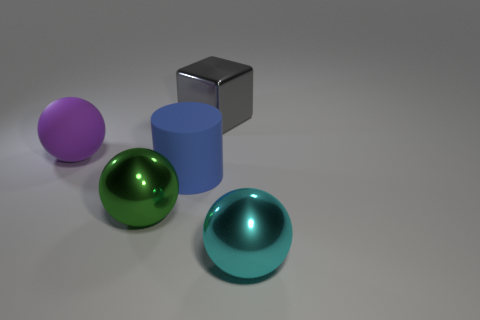There is a thing that is to the right of the green metallic object and in front of the large matte cylinder; what is its shape?
Ensure brevity in your answer.  Sphere. There is a object that is behind the green object and in front of the purple ball; what is its material?
Give a very brief answer. Rubber. Is the shape of the big metallic thing to the left of the large gray metallic object the same as the metal object that is on the right side of the gray cube?
Your response must be concise. Yes. Are any big spheres visible?
Give a very brief answer. Yes. There is another shiny thing that is the same shape as the cyan shiny thing; what is its color?
Provide a short and direct response. Green. The block that is the same size as the blue cylinder is what color?
Your answer should be compact. Gray. Do the green object and the large cyan sphere have the same material?
Keep it short and to the point. Yes. Do the large metal cube and the large rubber cylinder have the same color?
Offer a very short reply. No. What material is the thing left of the green thing?
Ensure brevity in your answer.  Rubber. What number of big things are either brown metallic things or green spheres?
Keep it short and to the point. 1. 